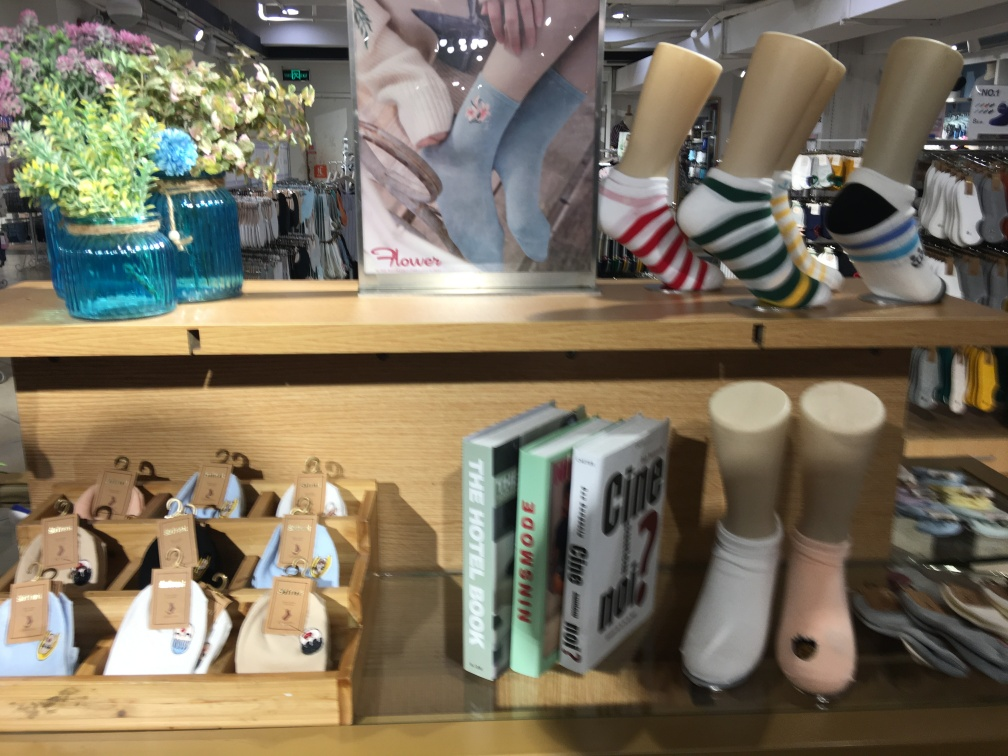Can you tell what kind of store this might be? Based on the items displayed—an assortment of socks, books, and decorative flowers—it appears to be a lifestyle or boutique store that caters to everyday fashion and leisure, possibly with a focus on travelers given the travel guide books. Do you think the presentation of these items is effective for attracting customers? The presentation is visually appealing and organized, which can attract customers. The clear categorization of items and the blend of functional (socks), inspirational (travel books), and decorative (flowers) elements create a pleasant shopping atmosphere. However, improving the clarity of the display and ensuring the image is in focus would enhance the attractiveness further. 